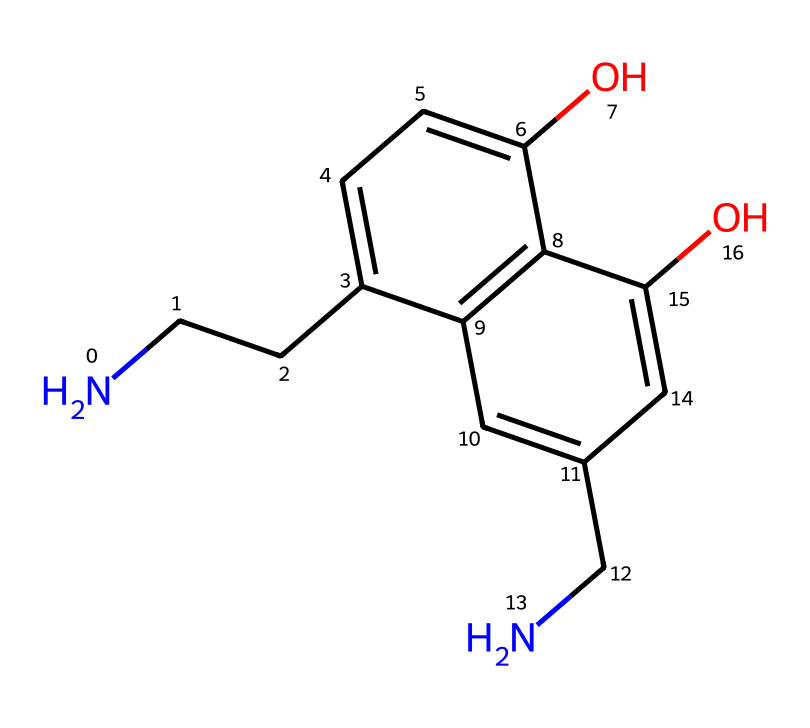What is the molecular formula of this chemical? By analyzing the given SMILES, we can count the types of atoms present: carbon (C), hydrogen (H), nitrogen (N), and oxygen (O). The structure shows 12 carbon atoms, 15 hydrogen atoms, 2 oxygen atoms, and 1 nitrogen atom. Thus, the molecular formula is C12H15N2O2.
Answer: C12H15N2O2 How many hydroxyl (-OH) groups are present in the structure? Looking closely at the chemical structure derived from the SMILES, there are two -OH groups identified by the presence of oxygen bound to hydrogen.
Answer: 2 What type of chemical is this compound classified as? The presence of a nitrogen atom and the functional groups indicates that it is an alkaloid, which are typically derived from plants and can affect the central nervous system.
Answer: alkaloid Which atoms are present in the largest quantity in this molecule? Evaluating the molecular formula C12H15N2O2, carbon (C) is the most abundant atom, with a count of 12.
Answer: carbon What is the significance of the nitrogen atom in this structure? The nitrogen atom in this structure suggests that it functions as a neurotransmitter or a precursor for neurotransmitters, linking its activity to the effects on serotonin and dopamine in the brain.
Answer: neurotransmitter Are there any substituents on the aromatic ring in this structure? Observing the SMILES, the presence of hydroxyl (-OH) groups indicates substituents attached to the aromatic ring - specifically, at the 1 and 2 positions on the ring based on their hydrogen status.
Answer: Yes 